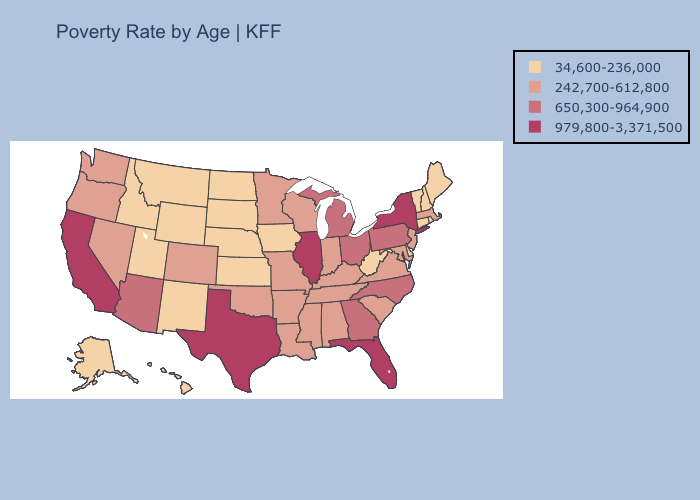Does the map have missing data?
Short answer required. No. What is the highest value in the South ?
Be succinct. 979,800-3,371,500. Name the states that have a value in the range 242,700-612,800?
Write a very short answer. Alabama, Arkansas, Colorado, Indiana, Kentucky, Louisiana, Maryland, Massachusetts, Minnesota, Mississippi, Missouri, Nevada, New Jersey, Oklahoma, Oregon, South Carolina, Tennessee, Virginia, Washington, Wisconsin. What is the lowest value in states that border Illinois?
Write a very short answer. 34,600-236,000. What is the value of New Hampshire?
Be succinct. 34,600-236,000. Does Texas have the highest value in the South?
Short answer required. Yes. What is the value of Florida?
Answer briefly. 979,800-3,371,500. How many symbols are there in the legend?
Be succinct. 4. What is the value of Mississippi?
Give a very brief answer. 242,700-612,800. Name the states that have a value in the range 34,600-236,000?
Be succinct. Alaska, Connecticut, Delaware, Hawaii, Idaho, Iowa, Kansas, Maine, Montana, Nebraska, New Hampshire, New Mexico, North Dakota, Rhode Island, South Dakota, Utah, Vermont, West Virginia, Wyoming. Does Connecticut have the lowest value in the USA?
Answer briefly. Yes. Name the states that have a value in the range 242,700-612,800?
Quick response, please. Alabama, Arkansas, Colorado, Indiana, Kentucky, Louisiana, Maryland, Massachusetts, Minnesota, Mississippi, Missouri, Nevada, New Jersey, Oklahoma, Oregon, South Carolina, Tennessee, Virginia, Washington, Wisconsin. Name the states that have a value in the range 242,700-612,800?
Short answer required. Alabama, Arkansas, Colorado, Indiana, Kentucky, Louisiana, Maryland, Massachusetts, Minnesota, Mississippi, Missouri, Nevada, New Jersey, Oklahoma, Oregon, South Carolina, Tennessee, Virginia, Washington, Wisconsin. Name the states that have a value in the range 979,800-3,371,500?
Answer briefly. California, Florida, Illinois, New York, Texas. 